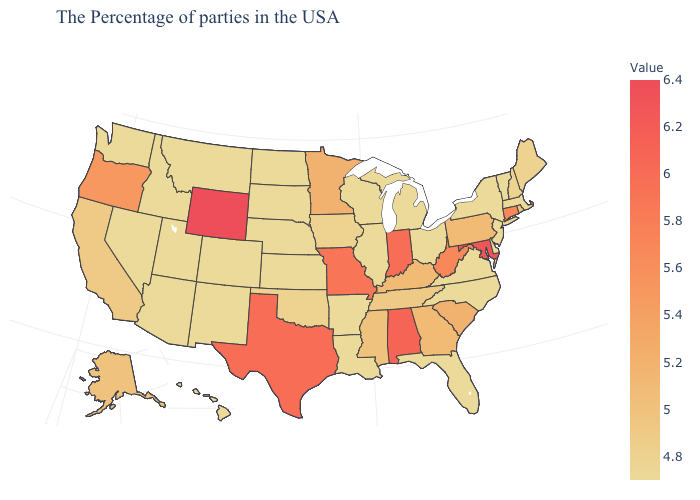Among the states that border Oklahoma , does Texas have the highest value?
Write a very short answer. Yes. Is the legend a continuous bar?
Be succinct. Yes. Which states have the lowest value in the West?
Write a very short answer. Colorado, New Mexico, Utah, Montana, Arizona, Idaho, Nevada, Washington, Hawaii. Which states have the lowest value in the USA?
Give a very brief answer. Massachusetts, Vermont, New York, New Jersey, Delaware, Virginia, North Carolina, Ohio, Florida, Michigan, Wisconsin, Illinois, Louisiana, Arkansas, Kansas, Nebraska, South Dakota, North Dakota, Colorado, New Mexico, Utah, Montana, Arizona, Idaho, Nevada, Washington, Hawaii. Is the legend a continuous bar?
Answer briefly. Yes. 